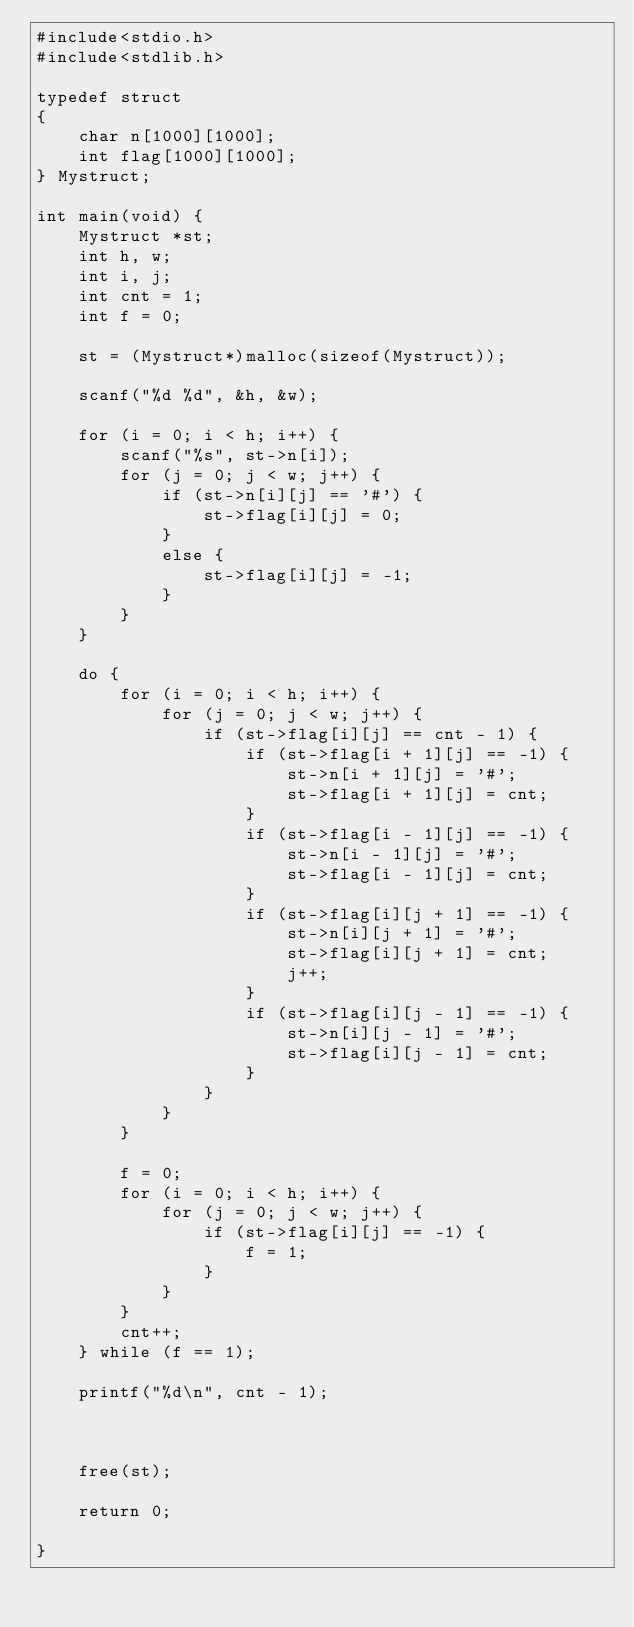<code> <loc_0><loc_0><loc_500><loc_500><_C_>#include<stdio.h>
#include<stdlib.h>

typedef struct 
{
	char n[1000][1000];
	int flag[1000][1000];
} Mystruct;

int main(void) {
	Mystruct *st;
	int h, w;
	int i, j;
	int cnt = 1;
	int f = 0;

	st = (Mystruct*)malloc(sizeof(Mystruct));

	scanf("%d %d", &h, &w);
	
	for (i = 0; i < h; i++) {
		scanf("%s", st->n[i]);
		for (j = 0; j < w; j++) {
			if (st->n[i][j] == '#') {
				st->flag[i][j] = 0;
			}
			else {
				st->flag[i][j] = -1;
			}
		}
	}

	do {
		for (i = 0; i < h; i++) {
			for (j = 0; j < w; j++) {
				if (st->flag[i][j] == cnt - 1) {
					if (st->flag[i + 1][j] == -1) {
						st->n[i + 1][j] = '#';
						st->flag[i + 1][j] = cnt;
					}
					if (st->flag[i - 1][j] == -1) {
						st->n[i - 1][j] = '#';
						st->flag[i - 1][j] = cnt;
					}
					if (st->flag[i][j + 1] == -1) {
						st->n[i][j + 1] = '#';
						st->flag[i][j + 1] = cnt;
						j++;
					}
					if (st->flag[i][j - 1] == -1) {
						st->n[i][j - 1] = '#';
						st->flag[i][j - 1] = cnt;
					}
				}
			}
		}

		f = 0;
		for (i = 0; i < h; i++) {
			for (j = 0; j < w; j++) {
				if (st->flag[i][j] == -1) {
					f = 1;
				}
			}
		}
		cnt++;
	} while (f == 1);

	printf("%d\n", cnt - 1);

	

	free(st);

	return 0;

}</code> 